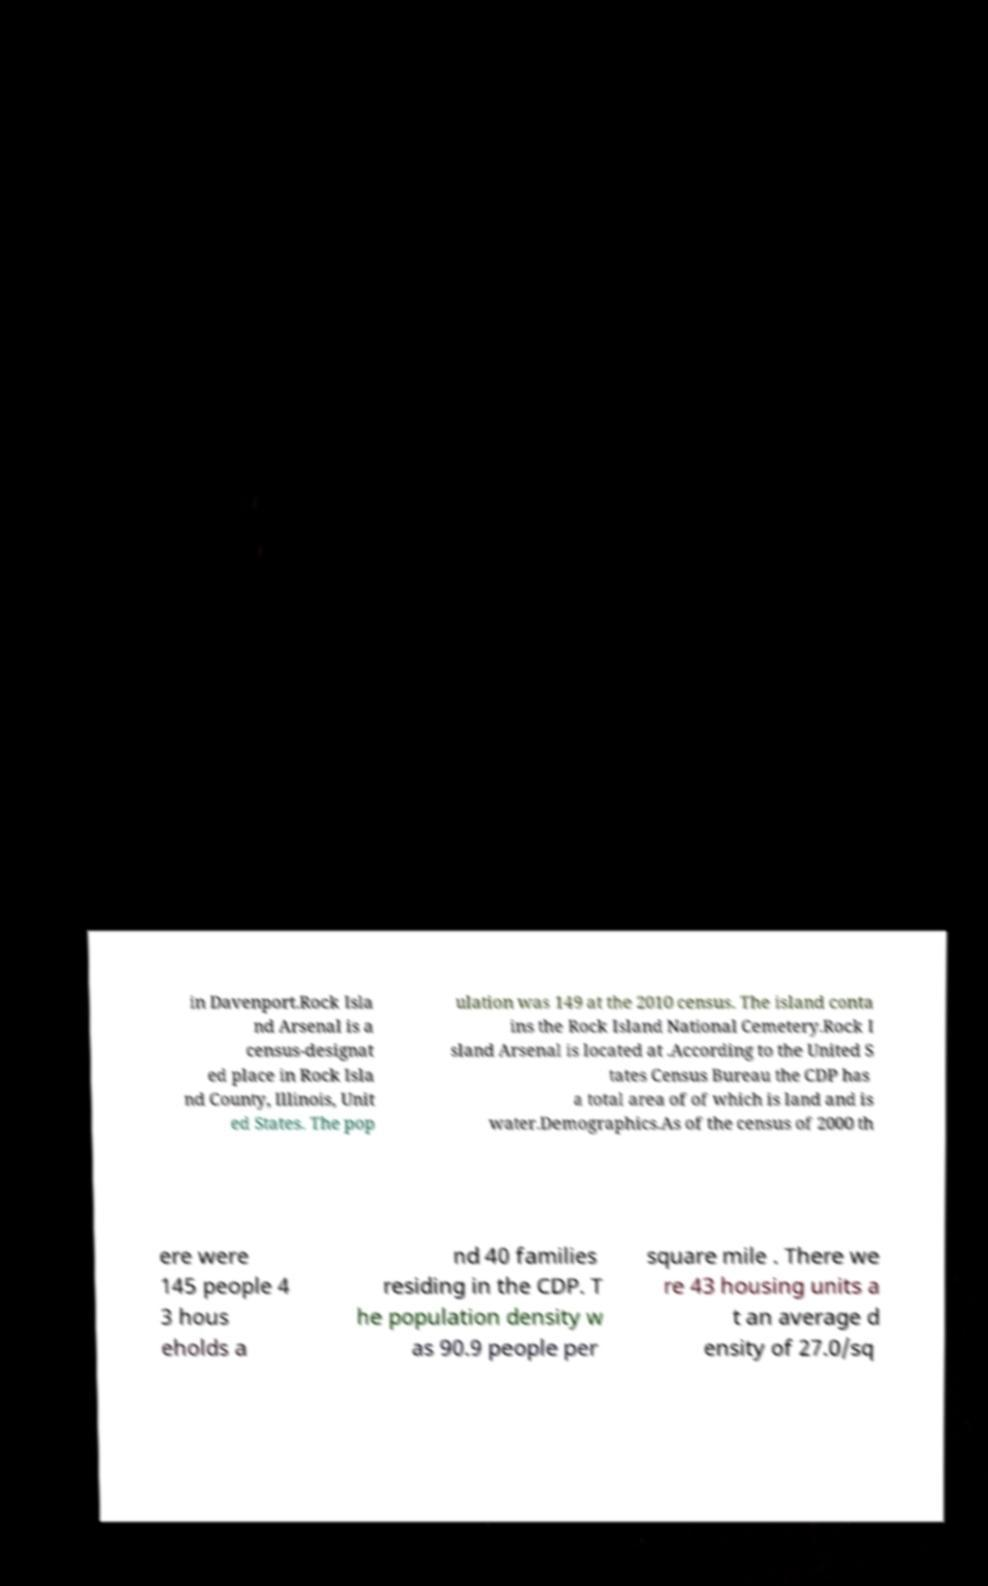Can you read and provide the text displayed in the image?This photo seems to have some interesting text. Can you extract and type it out for me? in Davenport.Rock Isla nd Arsenal is a census-designat ed place in Rock Isla nd County, Illinois, Unit ed States. The pop ulation was 149 at the 2010 census. The island conta ins the Rock Island National Cemetery.Rock I sland Arsenal is located at .According to the United S tates Census Bureau the CDP has a total area of of which is land and is water.Demographics.As of the census of 2000 th ere were 145 people 4 3 hous eholds a nd 40 families residing in the CDP. T he population density w as 90.9 people per square mile . There we re 43 housing units a t an average d ensity of 27.0/sq 